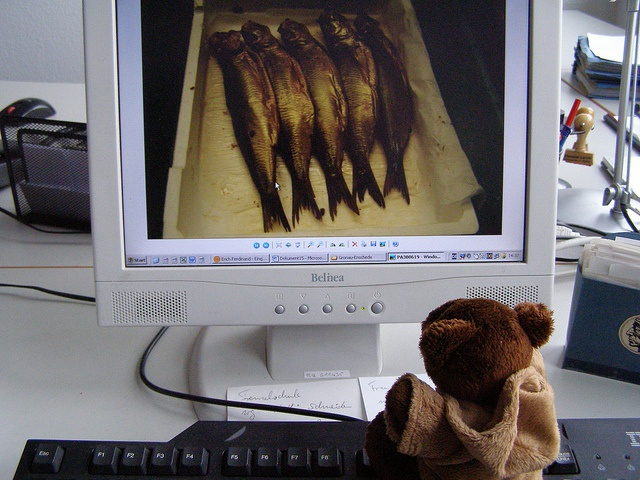Describe the objects in this image and their specific colors. I can see tv in gray, black, darkgray, and tan tones, teddy bear in gray, black, and maroon tones, keyboard in gray, black, navy, and blue tones, and mouse in gray, black, and darkgray tones in this image. 